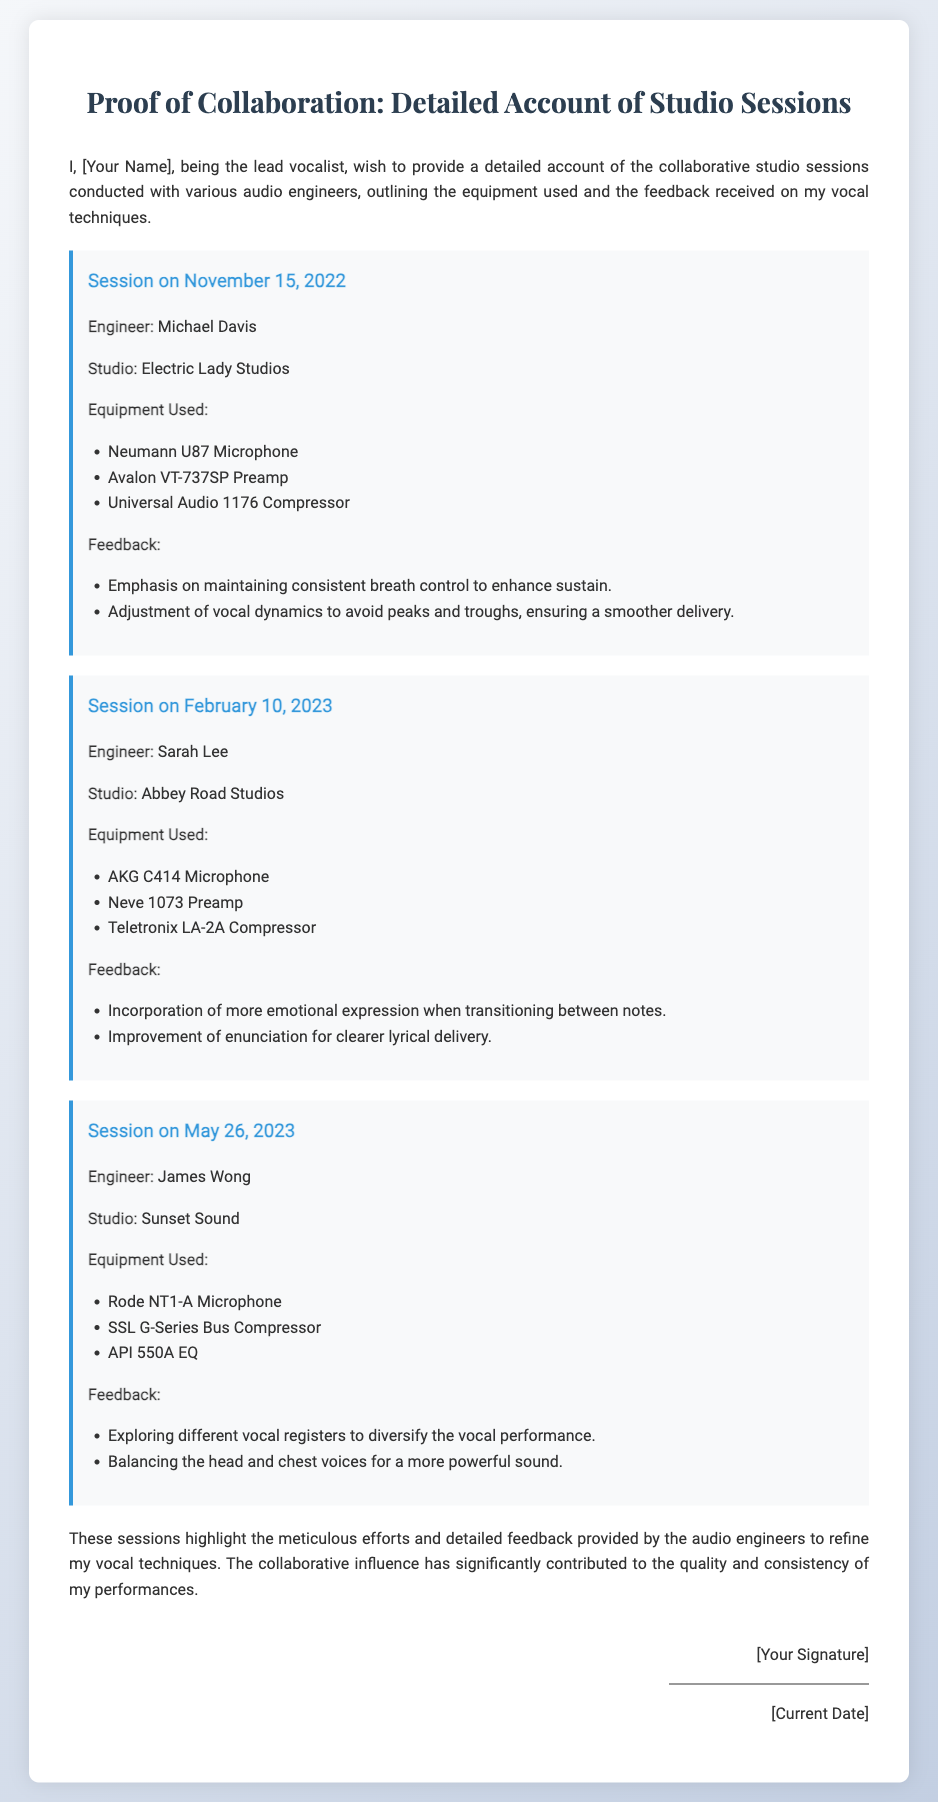What is the name of the first audio engineer? The first audio engineer mentioned in the document is Michael Davis.
Answer: Michael Davis What studio was used for the session on February 10, 2023? The studio used for the session on February 10, 2023, is Abbey Road Studios.
Answer: Abbey Road Studios How many different microphones were used in the sessions? The document lists three different microphones used: Neumann U87, AKG C414, and Rode NT1-A.
Answer: Three What feedback was given regarding vocal expression? The feedback included the incorporation of more emotional expression when transitioning between notes.
Answer: More emotional expression Which session took place on May 26, 2023? The session on May 26, 2023, was conducted with engineer James Wong at Sunset Sound.
Answer: James Wong at Sunset Sound What kind of document is this? This document is an affidavit detailing studio session collaborations and feedback.
Answer: Affidavit How does the singer describe the influence of the engineers? The singer describes the influence as significantly contributing to the quality and consistency of performances.
Answer: Significantly contributing What equipment was used during the session with Sarah Lee? The equipment used during the session with Sarah Lee included AKG C414 Microphone, Neve 1073 Preamp, and Teletronix LA-2A Compressor.
Answer: AKG C414 Microphone, Neve 1073 Preamp, Teletronix LA-2A Compressor 